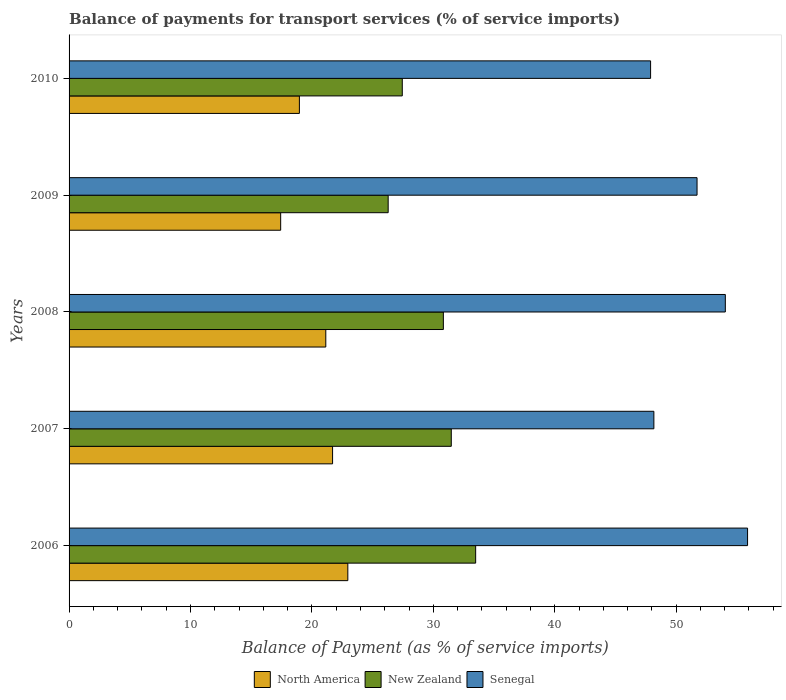How many different coloured bars are there?
Your answer should be very brief. 3. How many groups of bars are there?
Your answer should be very brief. 5. Are the number of bars on each tick of the Y-axis equal?
Your answer should be compact. Yes. How many bars are there on the 4th tick from the top?
Give a very brief answer. 3. How many bars are there on the 1st tick from the bottom?
Provide a short and direct response. 3. What is the label of the 2nd group of bars from the top?
Give a very brief answer. 2009. What is the balance of payments for transport services in Senegal in 2010?
Give a very brief answer. 47.9. Across all years, what is the maximum balance of payments for transport services in New Zealand?
Keep it short and to the point. 33.49. Across all years, what is the minimum balance of payments for transport services in Senegal?
Offer a terse response. 47.9. In which year was the balance of payments for transport services in Senegal minimum?
Your answer should be compact. 2010. What is the total balance of payments for transport services in Senegal in the graph?
Offer a very short reply. 257.72. What is the difference between the balance of payments for transport services in Senegal in 2006 and that in 2009?
Provide a succinct answer. 4.16. What is the difference between the balance of payments for transport services in New Zealand in 2010 and the balance of payments for transport services in Senegal in 2007?
Offer a terse response. -20.72. What is the average balance of payments for transport services in Senegal per year?
Keep it short and to the point. 51.54. In the year 2010, what is the difference between the balance of payments for transport services in North America and balance of payments for transport services in New Zealand?
Provide a short and direct response. -8.48. What is the ratio of the balance of payments for transport services in New Zealand in 2007 to that in 2008?
Offer a terse response. 1.02. What is the difference between the highest and the second highest balance of payments for transport services in New Zealand?
Give a very brief answer. 2.01. What is the difference between the highest and the lowest balance of payments for transport services in Senegal?
Make the answer very short. 7.99. In how many years, is the balance of payments for transport services in New Zealand greater than the average balance of payments for transport services in New Zealand taken over all years?
Your answer should be compact. 3. Is the sum of the balance of payments for transport services in North America in 2006 and 2010 greater than the maximum balance of payments for transport services in New Zealand across all years?
Your response must be concise. Yes. What does the 2nd bar from the top in 2009 represents?
Give a very brief answer. New Zealand. What does the 1st bar from the bottom in 2006 represents?
Provide a succinct answer. North America. Is it the case that in every year, the sum of the balance of payments for transport services in North America and balance of payments for transport services in Senegal is greater than the balance of payments for transport services in New Zealand?
Offer a very short reply. Yes. Are all the bars in the graph horizontal?
Make the answer very short. Yes. What is the difference between two consecutive major ticks on the X-axis?
Your answer should be very brief. 10. Does the graph contain grids?
Your answer should be compact. No. What is the title of the graph?
Give a very brief answer. Balance of payments for transport services (% of service imports). Does "Albania" appear as one of the legend labels in the graph?
Make the answer very short. No. What is the label or title of the X-axis?
Keep it short and to the point. Balance of Payment (as % of service imports). What is the Balance of Payment (as % of service imports) in North America in 2006?
Keep it short and to the point. 22.96. What is the Balance of Payment (as % of service imports) in New Zealand in 2006?
Offer a terse response. 33.49. What is the Balance of Payment (as % of service imports) in Senegal in 2006?
Keep it short and to the point. 55.88. What is the Balance of Payment (as % of service imports) of North America in 2007?
Your answer should be very brief. 21.7. What is the Balance of Payment (as % of service imports) in New Zealand in 2007?
Your answer should be compact. 31.48. What is the Balance of Payment (as % of service imports) in Senegal in 2007?
Give a very brief answer. 48.17. What is the Balance of Payment (as % of service imports) of North America in 2008?
Keep it short and to the point. 21.15. What is the Balance of Payment (as % of service imports) in New Zealand in 2008?
Make the answer very short. 30.83. What is the Balance of Payment (as % of service imports) in Senegal in 2008?
Ensure brevity in your answer.  54.05. What is the Balance of Payment (as % of service imports) in North America in 2009?
Offer a terse response. 17.43. What is the Balance of Payment (as % of service imports) in New Zealand in 2009?
Give a very brief answer. 26.28. What is the Balance of Payment (as % of service imports) of Senegal in 2009?
Give a very brief answer. 51.72. What is the Balance of Payment (as % of service imports) of North America in 2010?
Offer a terse response. 18.97. What is the Balance of Payment (as % of service imports) of New Zealand in 2010?
Give a very brief answer. 27.45. What is the Balance of Payment (as % of service imports) of Senegal in 2010?
Your response must be concise. 47.9. Across all years, what is the maximum Balance of Payment (as % of service imports) in North America?
Make the answer very short. 22.96. Across all years, what is the maximum Balance of Payment (as % of service imports) of New Zealand?
Make the answer very short. 33.49. Across all years, what is the maximum Balance of Payment (as % of service imports) of Senegal?
Offer a terse response. 55.88. Across all years, what is the minimum Balance of Payment (as % of service imports) in North America?
Keep it short and to the point. 17.43. Across all years, what is the minimum Balance of Payment (as % of service imports) in New Zealand?
Provide a succinct answer. 26.28. Across all years, what is the minimum Balance of Payment (as % of service imports) in Senegal?
Keep it short and to the point. 47.9. What is the total Balance of Payment (as % of service imports) in North America in the graph?
Your answer should be very brief. 102.21. What is the total Balance of Payment (as % of service imports) in New Zealand in the graph?
Provide a succinct answer. 149.52. What is the total Balance of Payment (as % of service imports) of Senegal in the graph?
Your answer should be very brief. 257.72. What is the difference between the Balance of Payment (as % of service imports) in North America in 2006 and that in 2007?
Offer a terse response. 1.26. What is the difference between the Balance of Payment (as % of service imports) of New Zealand in 2006 and that in 2007?
Your answer should be very brief. 2.01. What is the difference between the Balance of Payment (as % of service imports) in Senegal in 2006 and that in 2007?
Ensure brevity in your answer.  7.72. What is the difference between the Balance of Payment (as % of service imports) in North America in 2006 and that in 2008?
Your answer should be compact. 1.81. What is the difference between the Balance of Payment (as % of service imports) of New Zealand in 2006 and that in 2008?
Keep it short and to the point. 2.66. What is the difference between the Balance of Payment (as % of service imports) in Senegal in 2006 and that in 2008?
Offer a terse response. 1.83. What is the difference between the Balance of Payment (as % of service imports) in North America in 2006 and that in 2009?
Keep it short and to the point. 5.53. What is the difference between the Balance of Payment (as % of service imports) of New Zealand in 2006 and that in 2009?
Provide a succinct answer. 7.21. What is the difference between the Balance of Payment (as % of service imports) of Senegal in 2006 and that in 2009?
Provide a succinct answer. 4.16. What is the difference between the Balance of Payment (as % of service imports) of North America in 2006 and that in 2010?
Provide a succinct answer. 3.99. What is the difference between the Balance of Payment (as % of service imports) of New Zealand in 2006 and that in 2010?
Your answer should be very brief. 6.04. What is the difference between the Balance of Payment (as % of service imports) in Senegal in 2006 and that in 2010?
Provide a succinct answer. 7.99. What is the difference between the Balance of Payment (as % of service imports) in North America in 2007 and that in 2008?
Your answer should be very brief. 0.56. What is the difference between the Balance of Payment (as % of service imports) in New Zealand in 2007 and that in 2008?
Provide a succinct answer. 0.65. What is the difference between the Balance of Payment (as % of service imports) of Senegal in 2007 and that in 2008?
Ensure brevity in your answer.  -5.89. What is the difference between the Balance of Payment (as % of service imports) in North America in 2007 and that in 2009?
Your answer should be very brief. 4.27. What is the difference between the Balance of Payment (as % of service imports) of New Zealand in 2007 and that in 2009?
Provide a succinct answer. 5.2. What is the difference between the Balance of Payment (as % of service imports) in Senegal in 2007 and that in 2009?
Give a very brief answer. -3.56. What is the difference between the Balance of Payment (as % of service imports) in North America in 2007 and that in 2010?
Your answer should be very brief. 2.73. What is the difference between the Balance of Payment (as % of service imports) in New Zealand in 2007 and that in 2010?
Offer a terse response. 4.04. What is the difference between the Balance of Payment (as % of service imports) in Senegal in 2007 and that in 2010?
Your response must be concise. 0.27. What is the difference between the Balance of Payment (as % of service imports) in North America in 2008 and that in 2009?
Provide a short and direct response. 3.72. What is the difference between the Balance of Payment (as % of service imports) of New Zealand in 2008 and that in 2009?
Keep it short and to the point. 4.55. What is the difference between the Balance of Payment (as % of service imports) of Senegal in 2008 and that in 2009?
Ensure brevity in your answer.  2.33. What is the difference between the Balance of Payment (as % of service imports) in North America in 2008 and that in 2010?
Give a very brief answer. 2.18. What is the difference between the Balance of Payment (as % of service imports) in New Zealand in 2008 and that in 2010?
Offer a very short reply. 3.38. What is the difference between the Balance of Payment (as % of service imports) in Senegal in 2008 and that in 2010?
Make the answer very short. 6.16. What is the difference between the Balance of Payment (as % of service imports) of North America in 2009 and that in 2010?
Give a very brief answer. -1.54. What is the difference between the Balance of Payment (as % of service imports) of New Zealand in 2009 and that in 2010?
Offer a terse response. -1.16. What is the difference between the Balance of Payment (as % of service imports) of Senegal in 2009 and that in 2010?
Your answer should be compact. 3.83. What is the difference between the Balance of Payment (as % of service imports) in North America in 2006 and the Balance of Payment (as % of service imports) in New Zealand in 2007?
Offer a very short reply. -8.52. What is the difference between the Balance of Payment (as % of service imports) in North America in 2006 and the Balance of Payment (as % of service imports) in Senegal in 2007?
Provide a short and direct response. -25.21. What is the difference between the Balance of Payment (as % of service imports) in New Zealand in 2006 and the Balance of Payment (as % of service imports) in Senegal in 2007?
Offer a terse response. -14.68. What is the difference between the Balance of Payment (as % of service imports) of North America in 2006 and the Balance of Payment (as % of service imports) of New Zealand in 2008?
Provide a short and direct response. -7.87. What is the difference between the Balance of Payment (as % of service imports) of North America in 2006 and the Balance of Payment (as % of service imports) of Senegal in 2008?
Offer a terse response. -31.09. What is the difference between the Balance of Payment (as % of service imports) in New Zealand in 2006 and the Balance of Payment (as % of service imports) in Senegal in 2008?
Offer a very short reply. -20.56. What is the difference between the Balance of Payment (as % of service imports) in North America in 2006 and the Balance of Payment (as % of service imports) in New Zealand in 2009?
Offer a very short reply. -3.32. What is the difference between the Balance of Payment (as % of service imports) in North America in 2006 and the Balance of Payment (as % of service imports) in Senegal in 2009?
Provide a short and direct response. -28.76. What is the difference between the Balance of Payment (as % of service imports) in New Zealand in 2006 and the Balance of Payment (as % of service imports) in Senegal in 2009?
Offer a very short reply. -18.23. What is the difference between the Balance of Payment (as % of service imports) in North America in 2006 and the Balance of Payment (as % of service imports) in New Zealand in 2010?
Your response must be concise. -4.49. What is the difference between the Balance of Payment (as % of service imports) of North America in 2006 and the Balance of Payment (as % of service imports) of Senegal in 2010?
Keep it short and to the point. -24.94. What is the difference between the Balance of Payment (as % of service imports) in New Zealand in 2006 and the Balance of Payment (as % of service imports) in Senegal in 2010?
Ensure brevity in your answer.  -14.41. What is the difference between the Balance of Payment (as % of service imports) of North America in 2007 and the Balance of Payment (as % of service imports) of New Zealand in 2008?
Keep it short and to the point. -9.12. What is the difference between the Balance of Payment (as % of service imports) in North America in 2007 and the Balance of Payment (as % of service imports) in Senegal in 2008?
Offer a terse response. -32.35. What is the difference between the Balance of Payment (as % of service imports) of New Zealand in 2007 and the Balance of Payment (as % of service imports) of Senegal in 2008?
Provide a succinct answer. -22.57. What is the difference between the Balance of Payment (as % of service imports) of North America in 2007 and the Balance of Payment (as % of service imports) of New Zealand in 2009?
Provide a short and direct response. -4.58. What is the difference between the Balance of Payment (as % of service imports) in North America in 2007 and the Balance of Payment (as % of service imports) in Senegal in 2009?
Your answer should be compact. -30.02. What is the difference between the Balance of Payment (as % of service imports) in New Zealand in 2007 and the Balance of Payment (as % of service imports) in Senegal in 2009?
Your answer should be compact. -20.24. What is the difference between the Balance of Payment (as % of service imports) in North America in 2007 and the Balance of Payment (as % of service imports) in New Zealand in 2010?
Ensure brevity in your answer.  -5.74. What is the difference between the Balance of Payment (as % of service imports) of North America in 2007 and the Balance of Payment (as % of service imports) of Senegal in 2010?
Offer a terse response. -26.19. What is the difference between the Balance of Payment (as % of service imports) in New Zealand in 2007 and the Balance of Payment (as % of service imports) in Senegal in 2010?
Offer a very short reply. -16.42. What is the difference between the Balance of Payment (as % of service imports) in North America in 2008 and the Balance of Payment (as % of service imports) in New Zealand in 2009?
Make the answer very short. -5.14. What is the difference between the Balance of Payment (as % of service imports) of North America in 2008 and the Balance of Payment (as % of service imports) of Senegal in 2009?
Give a very brief answer. -30.58. What is the difference between the Balance of Payment (as % of service imports) of New Zealand in 2008 and the Balance of Payment (as % of service imports) of Senegal in 2009?
Give a very brief answer. -20.89. What is the difference between the Balance of Payment (as % of service imports) of North America in 2008 and the Balance of Payment (as % of service imports) of New Zealand in 2010?
Offer a very short reply. -6.3. What is the difference between the Balance of Payment (as % of service imports) of North America in 2008 and the Balance of Payment (as % of service imports) of Senegal in 2010?
Ensure brevity in your answer.  -26.75. What is the difference between the Balance of Payment (as % of service imports) in New Zealand in 2008 and the Balance of Payment (as % of service imports) in Senegal in 2010?
Provide a succinct answer. -17.07. What is the difference between the Balance of Payment (as % of service imports) in North America in 2009 and the Balance of Payment (as % of service imports) in New Zealand in 2010?
Offer a very short reply. -10.02. What is the difference between the Balance of Payment (as % of service imports) of North America in 2009 and the Balance of Payment (as % of service imports) of Senegal in 2010?
Offer a terse response. -30.47. What is the difference between the Balance of Payment (as % of service imports) in New Zealand in 2009 and the Balance of Payment (as % of service imports) in Senegal in 2010?
Offer a very short reply. -21.61. What is the average Balance of Payment (as % of service imports) in North America per year?
Provide a short and direct response. 20.44. What is the average Balance of Payment (as % of service imports) of New Zealand per year?
Ensure brevity in your answer.  29.9. What is the average Balance of Payment (as % of service imports) in Senegal per year?
Provide a short and direct response. 51.54. In the year 2006, what is the difference between the Balance of Payment (as % of service imports) in North America and Balance of Payment (as % of service imports) in New Zealand?
Give a very brief answer. -10.53. In the year 2006, what is the difference between the Balance of Payment (as % of service imports) of North America and Balance of Payment (as % of service imports) of Senegal?
Ensure brevity in your answer.  -32.92. In the year 2006, what is the difference between the Balance of Payment (as % of service imports) in New Zealand and Balance of Payment (as % of service imports) in Senegal?
Your response must be concise. -22.4. In the year 2007, what is the difference between the Balance of Payment (as % of service imports) in North America and Balance of Payment (as % of service imports) in New Zealand?
Your response must be concise. -9.78. In the year 2007, what is the difference between the Balance of Payment (as % of service imports) in North America and Balance of Payment (as % of service imports) in Senegal?
Keep it short and to the point. -26.46. In the year 2007, what is the difference between the Balance of Payment (as % of service imports) of New Zealand and Balance of Payment (as % of service imports) of Senegal?
Make the answer very short. -16.69. In the year 2008, what is the difference between the Balance of Payment (as % of service imports) in North America and Balance of Payment (as % of service imports) in New Zealand?
Ensure brevity in your answer.  -9.68. In the year 2008, what is the difference between the Balance of Payment (as % of service imports) in North America and Balance of Payment (as % of service imports) in Senegal?
Keep it short and to the point. -32.91. In the year 2008, what is the difference between the Balance of Payment (as % of service imports) of New Zealand and Balance of Payment (as % of service imports) of Senegal?
Ensure brevity in your answer.  -23.22. In the year 2009, what is the difference between the Balance of Payment (as % of service imports) in North America and Balance of Payment (as % of service imports) in New Zealand?
Your answer should be compact. -8.85. In the year 2009, what is the difference between the Balance of Payment (as % of service imports) of North America and Balance of Payment (as % of service imports) of Senegal?
Provide a short and direct response. -34.29. In the year 2009, what is the difference between the Balance of Payment (as % of service imports) of New Zealand and Balance of Payment (as % of service imports) of Senegal?
Provide a short and direct response. -25.44. In the year 2010, what is the difference between the Balance of Payment (as % of service imports) of North America and Balance of Payment (as % of service imports) of New Zealand?
Offer a very short reply. -8.48. In the year 2010, what is the difference between the Balance of Payment (as % of service imports) of North America and Balance of Payment (as % of service imports) of Senegal?
Give a very brief answer. -28.93. In the year 2010, what is the difference between the Balance of Payment (as % of service imports) of New Zealand and Balance of Payment (as % of service imports) of Senegal?
Ensure brevity in your answer.  -20.45. What is the ratio of the Balance of Payment (as % of service imports) of North America in 2006 to that in 2007?
Provide a succinct answer. 1.06. What is the ratio of the Balance of Payment (as % of service imports) of New Zealand in 2006 to that in 2007?
Make the answer very short. 1.06. What is the ratio of the Balance of Payment (as % of service imports) of Senegal in 2006 to that in 2007?
Give a very brief answer. 1.16. What is the ratio of the Balance of Payment (as % of service imports) of North America in 2006 to that in 2008?
Offer a very short reply. 1.09. What is the ratio of the Balance of Payment (as % of service imports) of New Zealand in 2006 to that in 2008?
Provide a succinct answer. 1.09. What is the ratio of the Balance of Payment (as % of service imports) of Senegal in 2006 to that in 2008?
Provide a short and direct response. 1.03. What is the ratio of the Balance of Payment (as % of service imports) in North America in 2006 to that in 2009?
Your answer should be very brief. 1.32. What is the ratio of the Balance of Payment (as % of service imports) in New Zealand in 2006 to that in 2009?
Your answer should be very brief. 1.27. What is the ratio of the Balance of Payment (as % of service imports) in Senegal in 2006 to that in 2009?
Ensure brevity in your answer.  1.08. What is the ratio of the Balance of Payment (as % of service imports) of North America in 2006 to that in 2010?
Your response must be concise. 1.21. What is the ratio of the Balance of Payment (as % of service imports) of New Zealand in 2006 to that in 2010?
Offer a very short reply. 1.22. What is the ratio of the Balance of Payment (as % of service imports) of Senegal in 2006 to that in 2010?
Your answer should be compact. 1.17. What is the ratio of the Balance of Payment (as % of service imports) of North America in 2007 to that in 2008?
Ensure brevity in your answer.  1.03. What is the ratio of the Balance of Payment (as % of service imports) in New Zealand in 2007 to that in 2008?
Make the answer very short. 1.02. What is the ratio of the Balance of Payment (as % of service imports) of Senegal in 2007 to that in 2008?
Provide a succinct answer. 0.89. What is the ratio of the Balance of Payment (as % of service imports) in North America in 2007 to that in 2009?
Offer a very short reply. 1.25. What is the ratio of the Balance of Payment (as % of service imports) of New Zealand in 2007 to that in 2009?
Your answer should be very brief. 1.2. What is the ratio of the Balance of Payment (as % of service imports) in Senegal in 2007 to that in 2009?
Provide a short and direct response. 0.93. What is the ratio of the Balance of Payment (as % of service imports) in North America in 2007 to that in 2010?
Your response must be concise. 1.14. What is the ratio of the Balance of Payment (as % of service imports) in New Zealand in 2007 to that in 2010?
Your answer should be very brief. 1.15. What is the ratio of the Balance of Payment (as % of service imports) of Senegal in 2007 to that in 2010?
Ensure brevity in your answer.  1.01. What is the ratio of the Balance of Payment (as % of service imports) in North America in 2008 to that in 2009?
Your response must be concise. 1.21. What is the ratio of the Balance of Payment (as % of service imports) of New Zealand in 2008 to that in 2009?
Keep it short and to the point. 1.17. What is the ratio of the Balance of Payment (as % of service imports) in Senegal in 2008 to that in 2009?
Provide a succinct answer. 1.04. What is the ratio of the Balance of Payment (as % of service imports) in North America in 2008 to that in 2010?
Offer a very short reply. 1.11. What is the ratio of the Balance of Payment (as % of service imports) in New Zealand in 2008 to that in 2010?
Your answer should be compact. 1.12. What is the ratio of the Balance of Payment (as % of service imports) in Senegal in 2008 to that in 2010?
Offer a very short reply. 1.13. What is the ratio of the Balance of Payment (as % of service imports) of North America in 2009 to that in 2010?
Provide a succinct answer. 0.92. What is the ratio of the Balance of Payment (as % of service imports) of New Zealand in 2009 to that in 2010?
Your answer should be compact. 0.96. What is the ratio of the Balance of Payment (as % of service imports) in Senegal in 2009 to that in 2010?
Keep it short and to the point. 1.08. What is the difference between the highest and the second highest Balance of Payment (as % of service imports) of North America?
Offer a terse response. 1.26. What is the difference between the highest and the second highest Balance of Payment (as % of service imports) of New Zealand?
Provide a succinct answer. 2.01. What is the difference between the highest and the second highest Balance of Payment (as % of service imports) in Senegal?
Your response must be concise. 1.83. What is the difference between the highest and the lowest Balance of Payment (as % of service imports) in North America?
Your response must be concise. 5.53. What is the difference between the highest and the lowest Balance of Payment (as % of service imports) in New Zealand?
Offer a very short reply. 7.21. What is the difference between the highest and the lowest Balance of Payment (as % of service imports) in Senegal?
Your answer should be very brief. 7.99. 